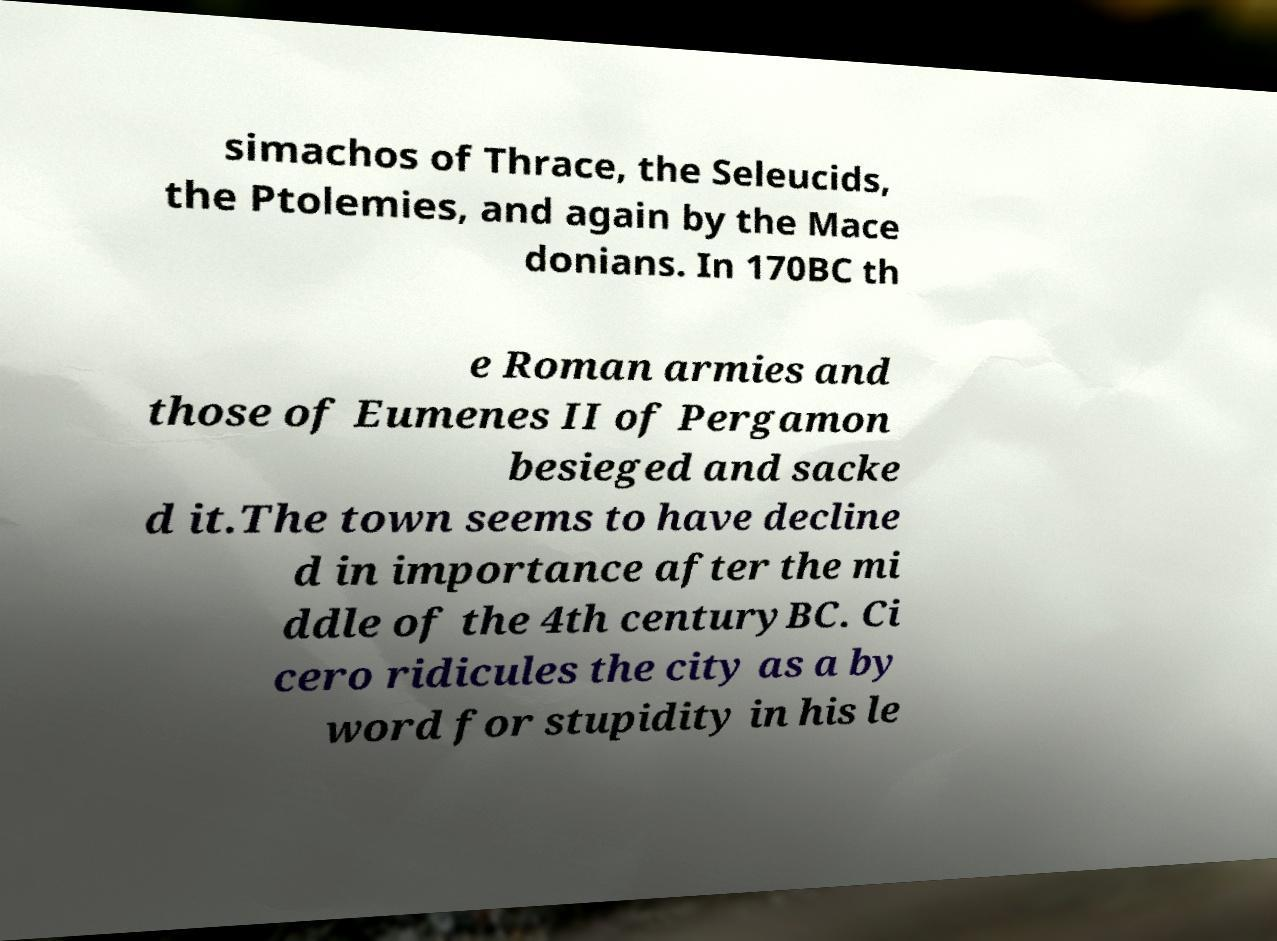What messages or text are displayed in this image? I need them in a readable, typed format. simachos of Thrace, the Seleucids, the Ptolemies, and again by the Mace donians. In 170BC th e Roman armies and those of Eumenes II of Pergamon besieged and sacke d it.The town seems to have decline d in importance after the mi ddle of the 4th centuryBC. Ci cero ridicules the city as a by word for stupidity in his le 